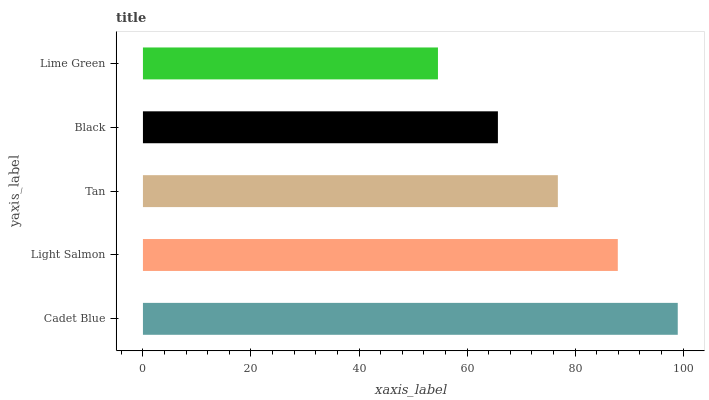Is Lime Green the minimum?
Answer yes or no. Yes. Is Cadet Blue the maximum?
Answer yes or no. Yes. Is Light Salmon the minimum?
Answer yes or no. No. Is Light Salmon the maximum?
Answer yes or no. No. Is Cadet Blue greater than Light Salmon?
Answer yes or no. Yes. Is Light Salmon less than Cadet Blue?
Answer yes or no. Yes. Is Light Salmon greater than Cadet Blue?
Answer yes or no. No. Is Cadet Blue less than Light Salmon?
Answer yes or no. No. Is Tan the high median?
Answer yes or no. Yes. Is Tan the low median?
Answer yes or no. Yes. Is Lime Green the high median?
Answer yes or no. No. Is Cadet Blue the low median?
Answer yes or no. No. 